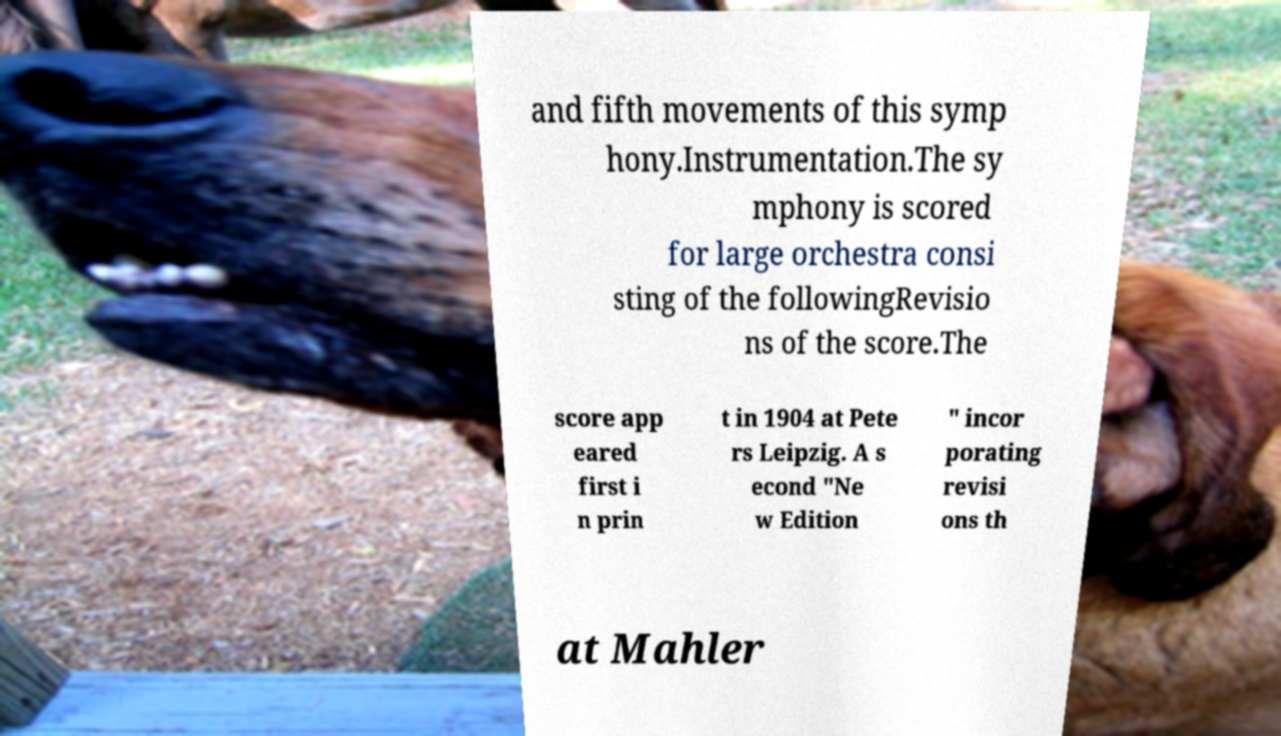I need the written content from this picture converted into text. Can you do that? and fifth movements of this symp hony.Instrumentation.The sy mphony is scored for large orchestra consi sting of the followingRevisio ns of the score.The score app eared first i n prin t in 1904 at Pete rs Leipzig. A s econd "Ne w Edition " incor porating revisi ons th at Mahler 